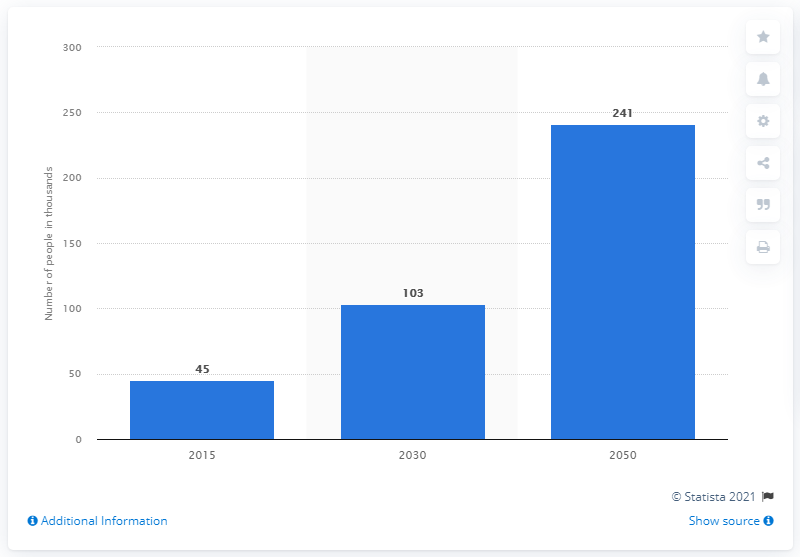Identify some key points in this picture. The average projection of dementia is 129.67. The year with the highest projected number of people is 2050. 